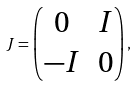Convert formula to latex. <formula><loc_0><loc_0><loc_500><loc_500>J = \begin{pmatrix} 0 & I \\ - I & 0 \end{pmatrix} ,</formula> 